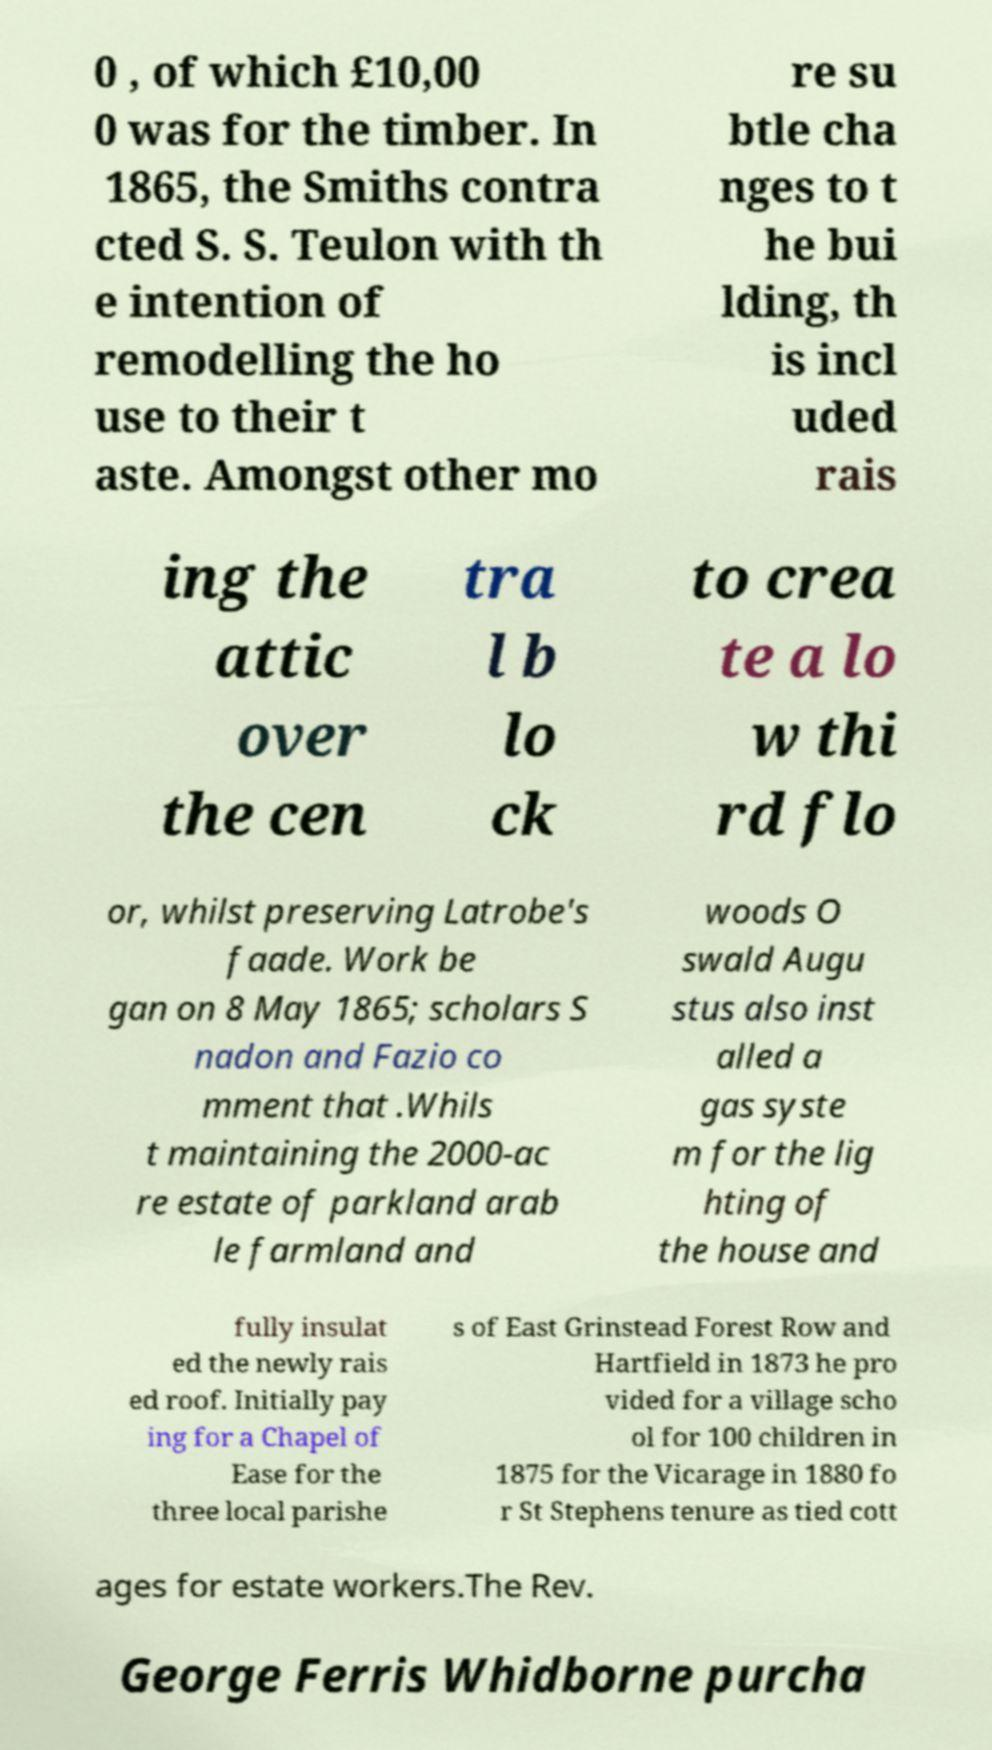Could you assist in decoding the text presented in this image and type it out clearly? 0 , of which £10,00 0 was for the timber. In 1865, the Smiths contra cted S. S. Teulon with th e intention of remodelling the ho use to their t aste. Amongst other mo re su btle cha nges to t he bui lding, th is incl uded rais ing the attic over the cen tra l b lo ck to crea te a lo w thi rd flo or, whilst preserving Latrobe's faade. Work be gan on 8 May 1865; scholars S nadon and Fazio co mment that .Whils t maintaining the 2000-ac re estate of parkland arab le farmland and woods O swald Augu stus also inst alled a gas syste m for the lig hting of the house and fully insulat ed the newly rais ed roof. Initially pay ing for a Chapel of Ease for the three local parishe s of East Grinstead Forest Row and Hartfield in 1873 he pro vided for a village scho ol for 100 children in 1875 for the Vicarage in 1880 fo r St Stephens tenure as tied cott ages for estate workers.The Rev. George Ferris Whidborne purcha 